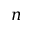<formula> <loc_0><loc_0><loc_500><loc_500>n</formula> 